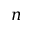<formula> <loc_0><loc_0><loc_500><loc_500>n</formula> 